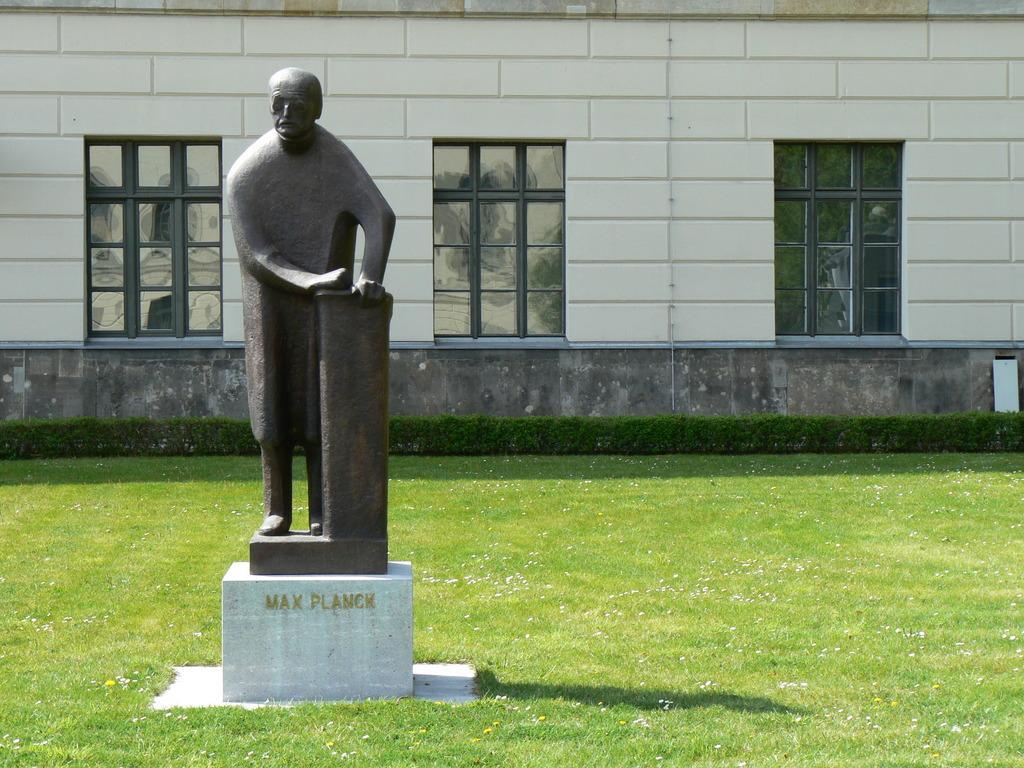How would you summarize this image in a sentence or two? In this picture I can see the statue. I can see the glass windows. I can see green grass. 